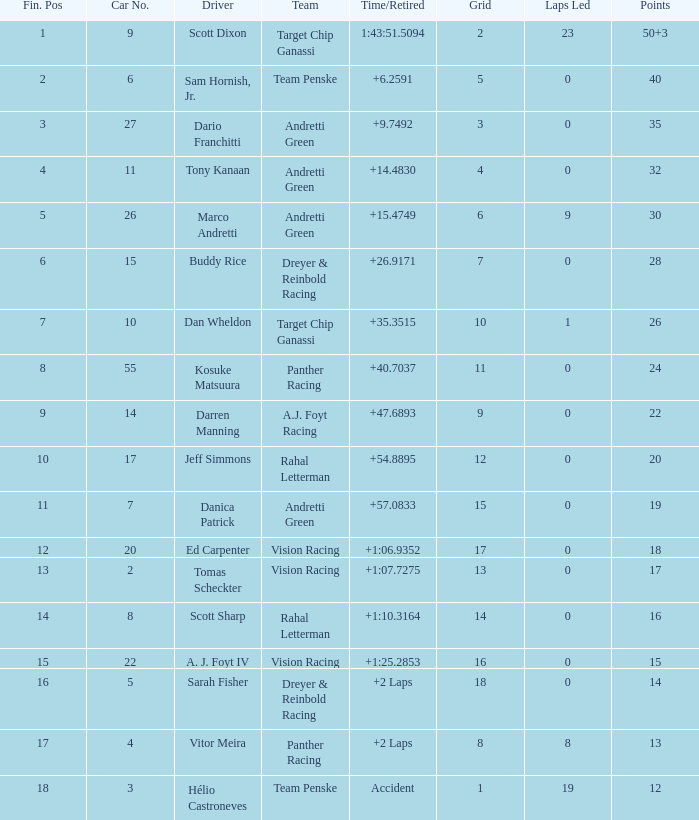Name the laps for 18 pointss 60.0. 